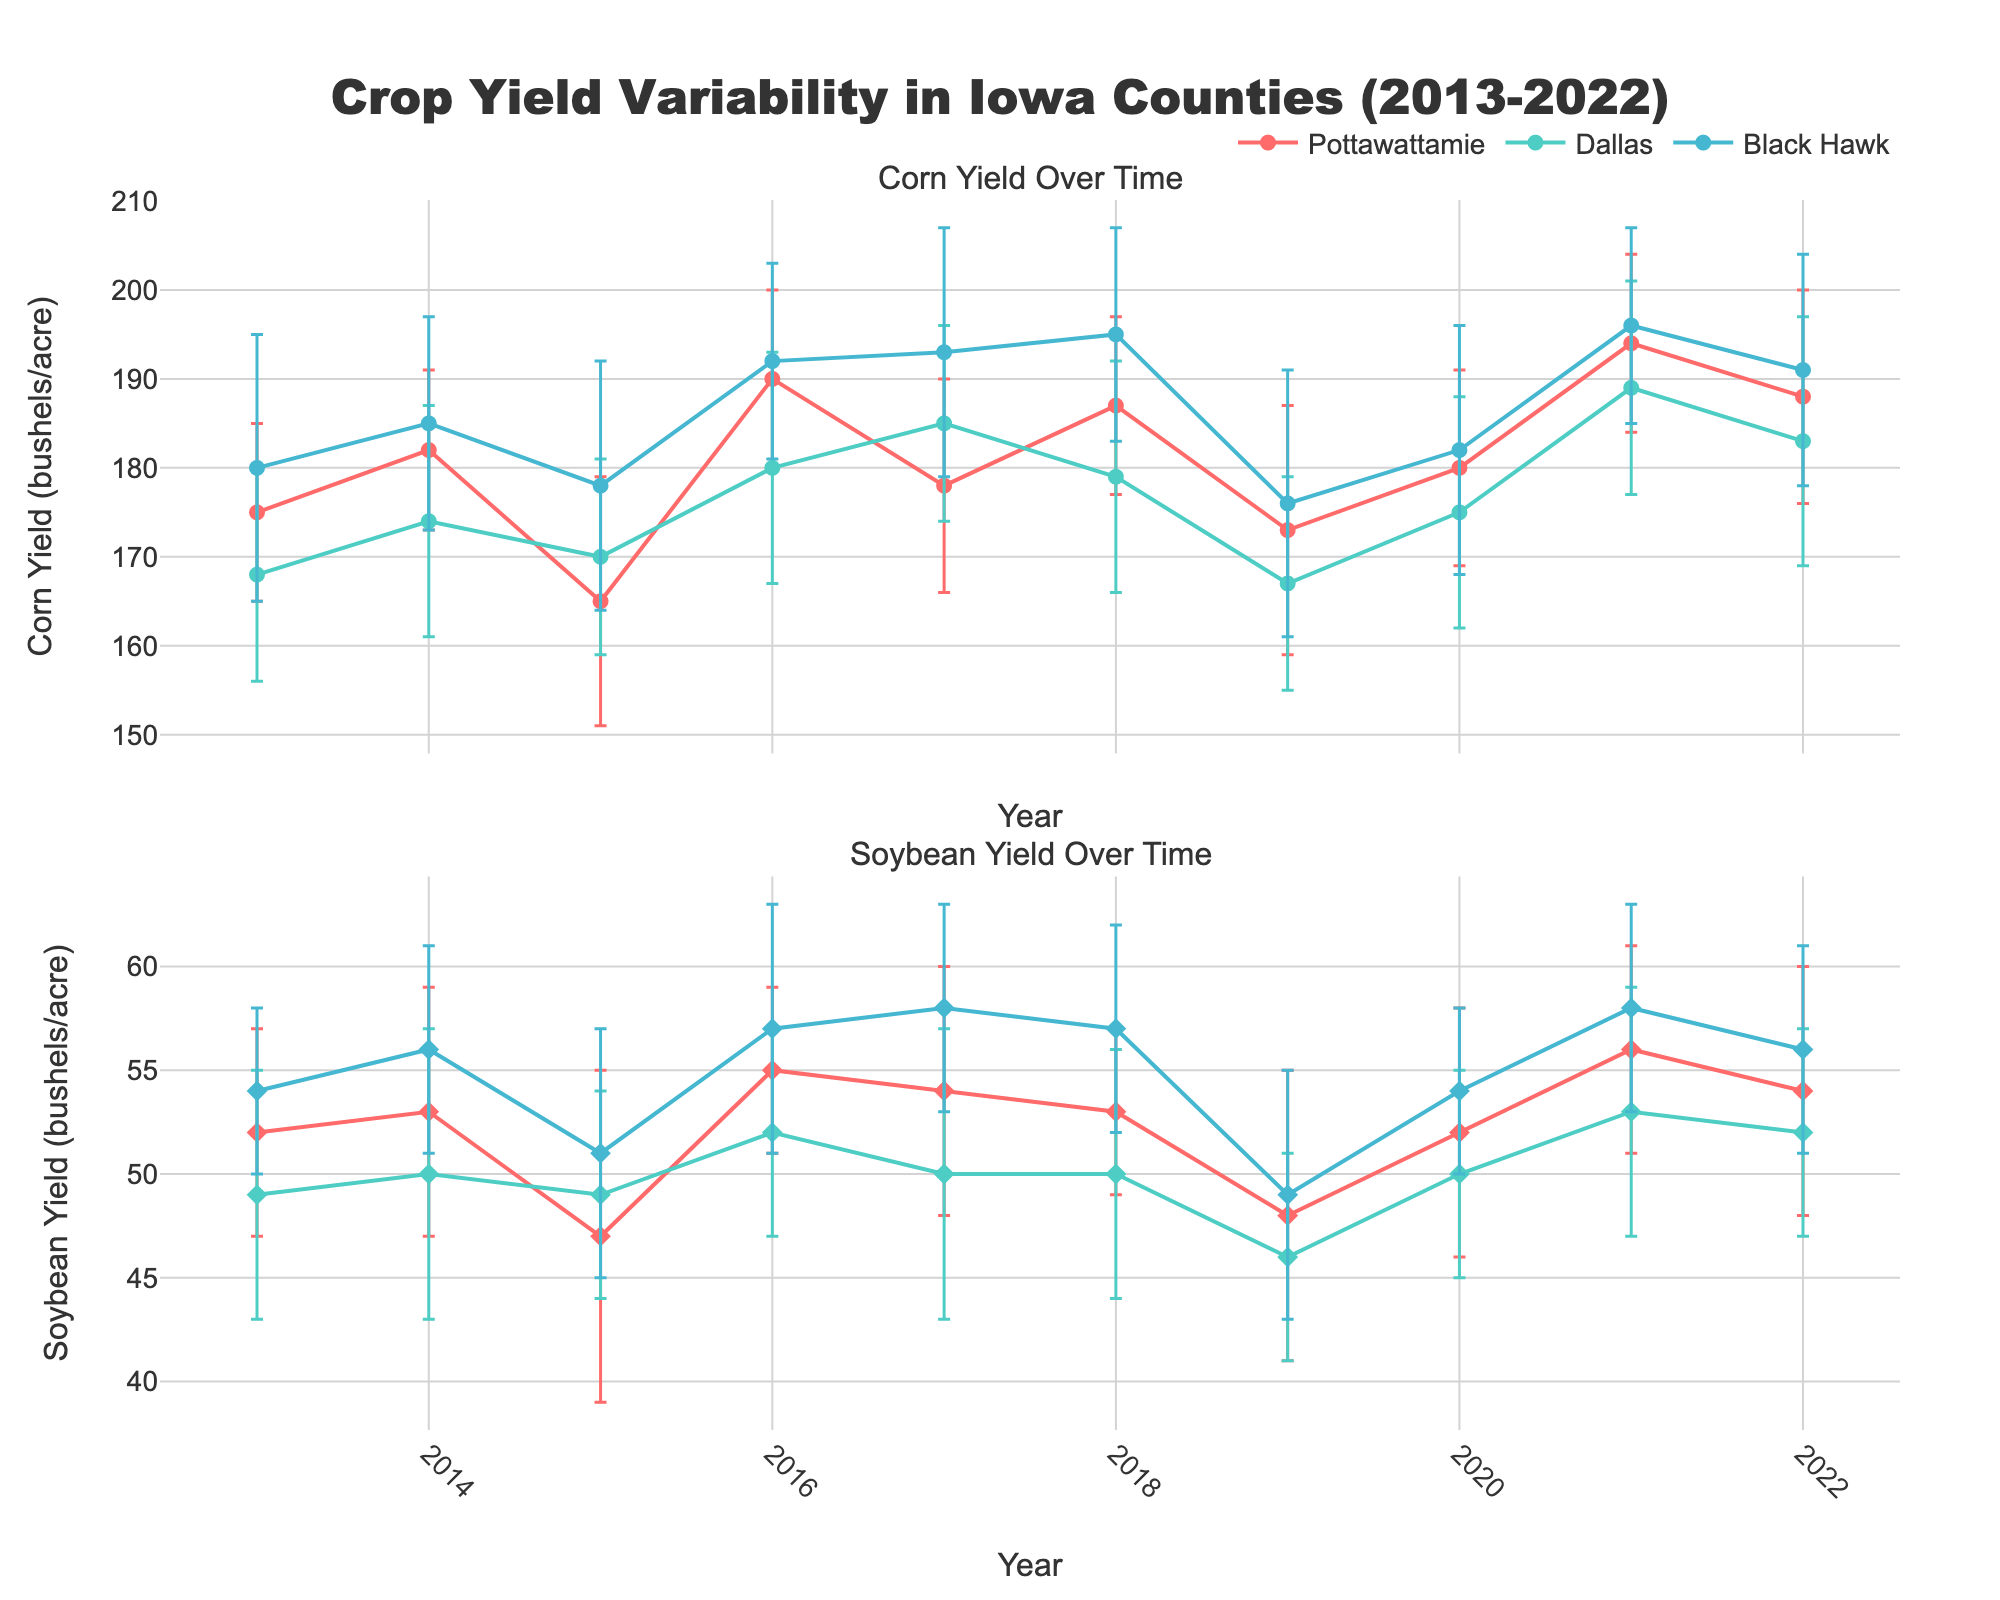Which county had the highest corn yield in 2014? Look at the first subplot for 2014 and identify the peak point. This is Black Hawk County.
Answer: Black Hawk What is the title of the figure? Read the text above the plots.
Answer: "Crop Yield Variability in Iowa Counties (2013-2022)" How many years of data are displayed in the figure? Count the tick marks on the x-axis of either subplot. From 2013 to 2022, there are 10 years.
Answer: 10 What's the difference in corn yield between Pottawattamie and Dallas counties in 2016? Find the corn yields for both counties in 2016 from the first subplot and subtract them. Pottawattamie has 190 and Dallas has 180.
Answer: 10 bushels/acre Which county showed the highest variation in soybean yield in 2013? Compare the error bars for soybean yield in 2013 in the second subplot. Dallas has the highest standard deviation (6).
Answer: Dallas How does the soybean yield of Black Hawk in 2022 compare to its yield in 2013? Look at Black Hawk's soybean yield in 2013 and 2022 on the second subplot and compare the values. 2013 is 54 and 2022 is 56, so it increased.
Answer: Increased by 2 bushels/acre Which subplot specifically displays soybean yield data? Determine which subplot title mentions soybean yield.
Answer: The second subplot What is the average corn yield for Black Hawk County across the entire decade? Add up all yearly corn yields for Black Hawk County and divide by the total number of years. (180 + 185 + 178 + 192 + 193 + 195 + 176 + 182 + 196 + 191) / 10 = 186.8
Answer: 186.8 bushels/acre Did Pottawattamie County's corn yield ever drop below 170 bushels/acre within these 10 years? Check the first subplot for any points in Pottawattamie below the 170 line. Only 2015 has a yield of 165.
Answer: Yes Which county had the lowest soybean yield in 2020? Find the data points for 2020 in the second subplot and identify the lowest value. Dallas has 50.
Answer: Dallas 